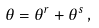<formula> <loc_0><loc_0><loc_500><loc_500>\theta = \theta ^ { r } + \theta ^ { s } \, ,</formula> 